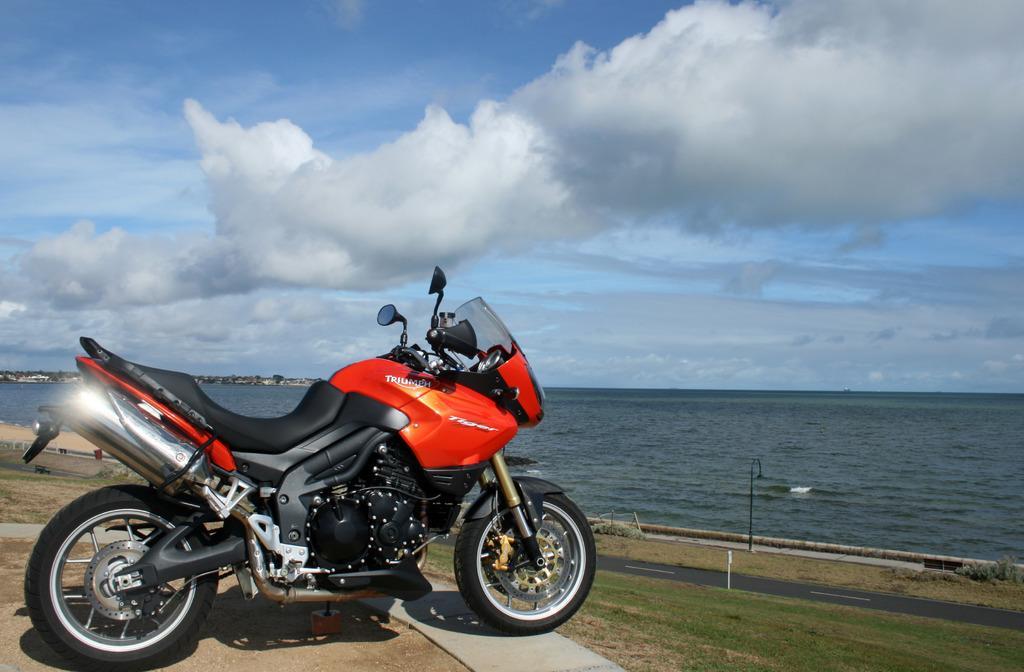In one or two sentences, can you explain what this image depicts? In this image there is a bike parked on the surface, in front of the bike there is grass, road, in the background of the image there is water. 